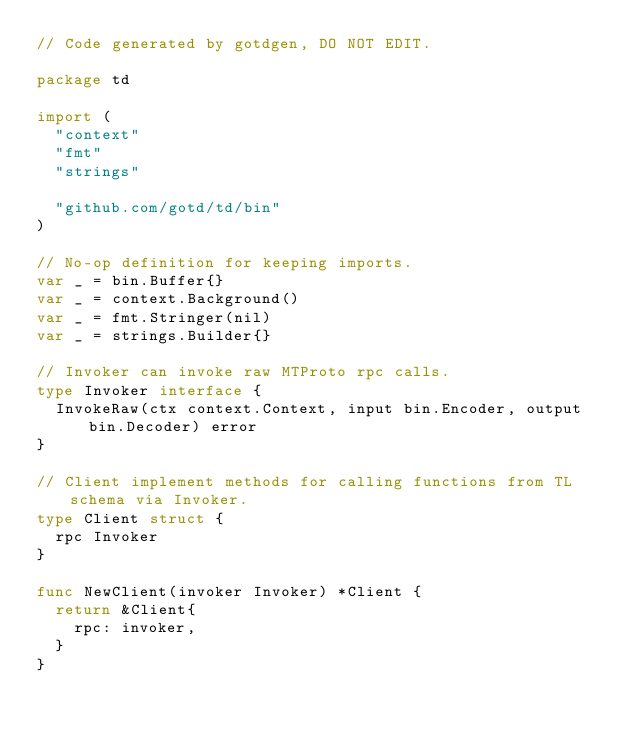<code> <loc_0><loc_0><loc_500><loc_500><_Go_>// Code generated by gotdgen, DO NOT EDIT.

package td

import (
	"context"
	"fmt"
	"strings"

	"github.com/gotd/td/bin"
)

// No-op definition for keeping imports.
var _ = bin.Buffer{}
var _ = context.Background()
var _ = fmt.Stringer(nil)
var _ = strings.Builder{}

// Invoker can invoke raw MTProto rpc calls.
type Invoker interface {
	InvokeRaw(ctx context.Context, input bin.Encoder, output bin.Decoder) error
}

// Client implement methods for calling functions from TL schema via Invoker.
type Client struct {
	rpc Invoker
}

func NewClient(invoker Invoker) *Client {
	return &Client{
		rpc: invoker,
	}
}
</code> 